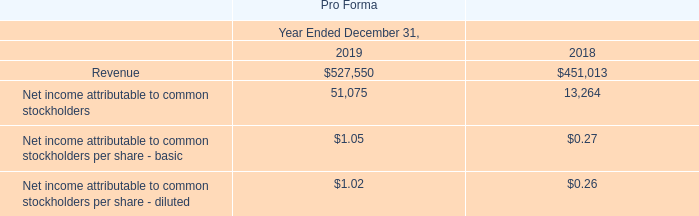Unaudited Pro Forma Information - OpenEye
The following unaudited pro forma data is presented as if OpenEye were included in our historical consolidated statements of operations beginning January 1, 2018. These pro forma results do not necessarily represent what would have occurred if all the business combination had taken place on January 1, 2018, nor do they represent the results that may occur in the future.
This pro forma financial information includes our historical financial statements and those of our OpenEye business combination with the following adjustments: (i) we adjusted the pro forma amounts for income taxes, (ii) we adjusted for amortization expense assuming the fair value adjustments to intangible assets had been applied beginning January 1, 2018, and (iii) we adjusted for transaction fees incurred and reclassified them to January 1, 2018.
The pro forma adjustments were based on available information and upon assumptions that we believe are reasonable to reflect the impact of these acquisitions on our historical financial information on a supplemental pro forma basis, as follows (in thousands, except per share data):
Which years does the table provide information for revenue? 2019, 2018. What was the net income attributable to common stockholders in 2018?
Answer scale should be: thousand. 13,264. What was the Net income attributable to common stockholders per share - basic in 2019? $1.05. What was the change in the Net income attributable to common stockholders per share - diluted between 2018 and 2019? 1.02-0.26
Answer: 0.76. What was the change in the Net income attributable to common stockholders between 2018 and 2019?
Answer scale should be: thousand. 51,075-13,264
Answer: 37811. What was the percentage change in the revenue between 2018 and 2019?
Answer scale should be: percent. (527,550-451,013)/451,013
Answer: 16.97. 